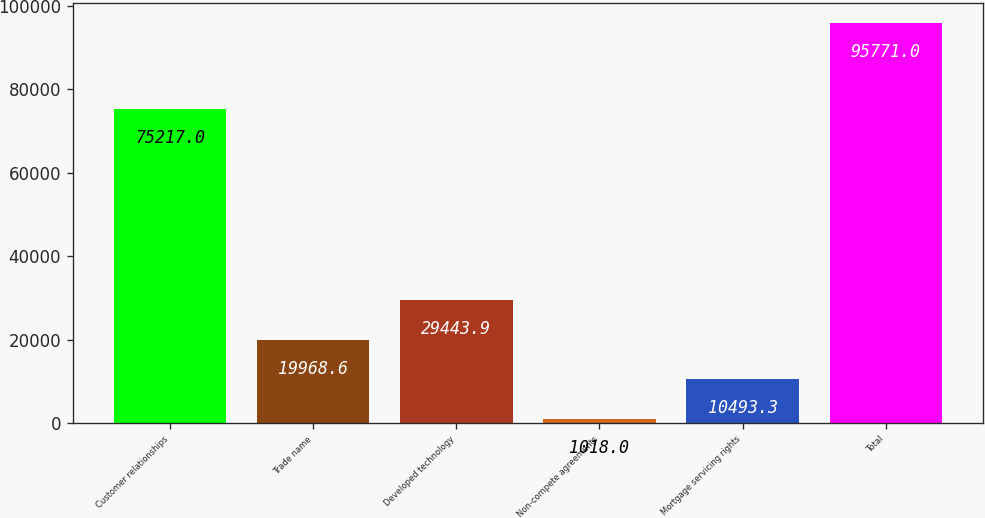Convert chart to OTSL. <chart><loc_0><loc_0><loc_500><loc_500><bar_chart><fcel>Customer relationships<fcel>Trade name<fcel>Developed technology<fcel>Non-compete agreements<fcel>Mortgage servicing rights<fcel>Total<nl><fcel>75217<fcel>19968.6<fcel>29443.9<fcel>1018<fcel>10493.3<fcel>95771<nl></chart> 